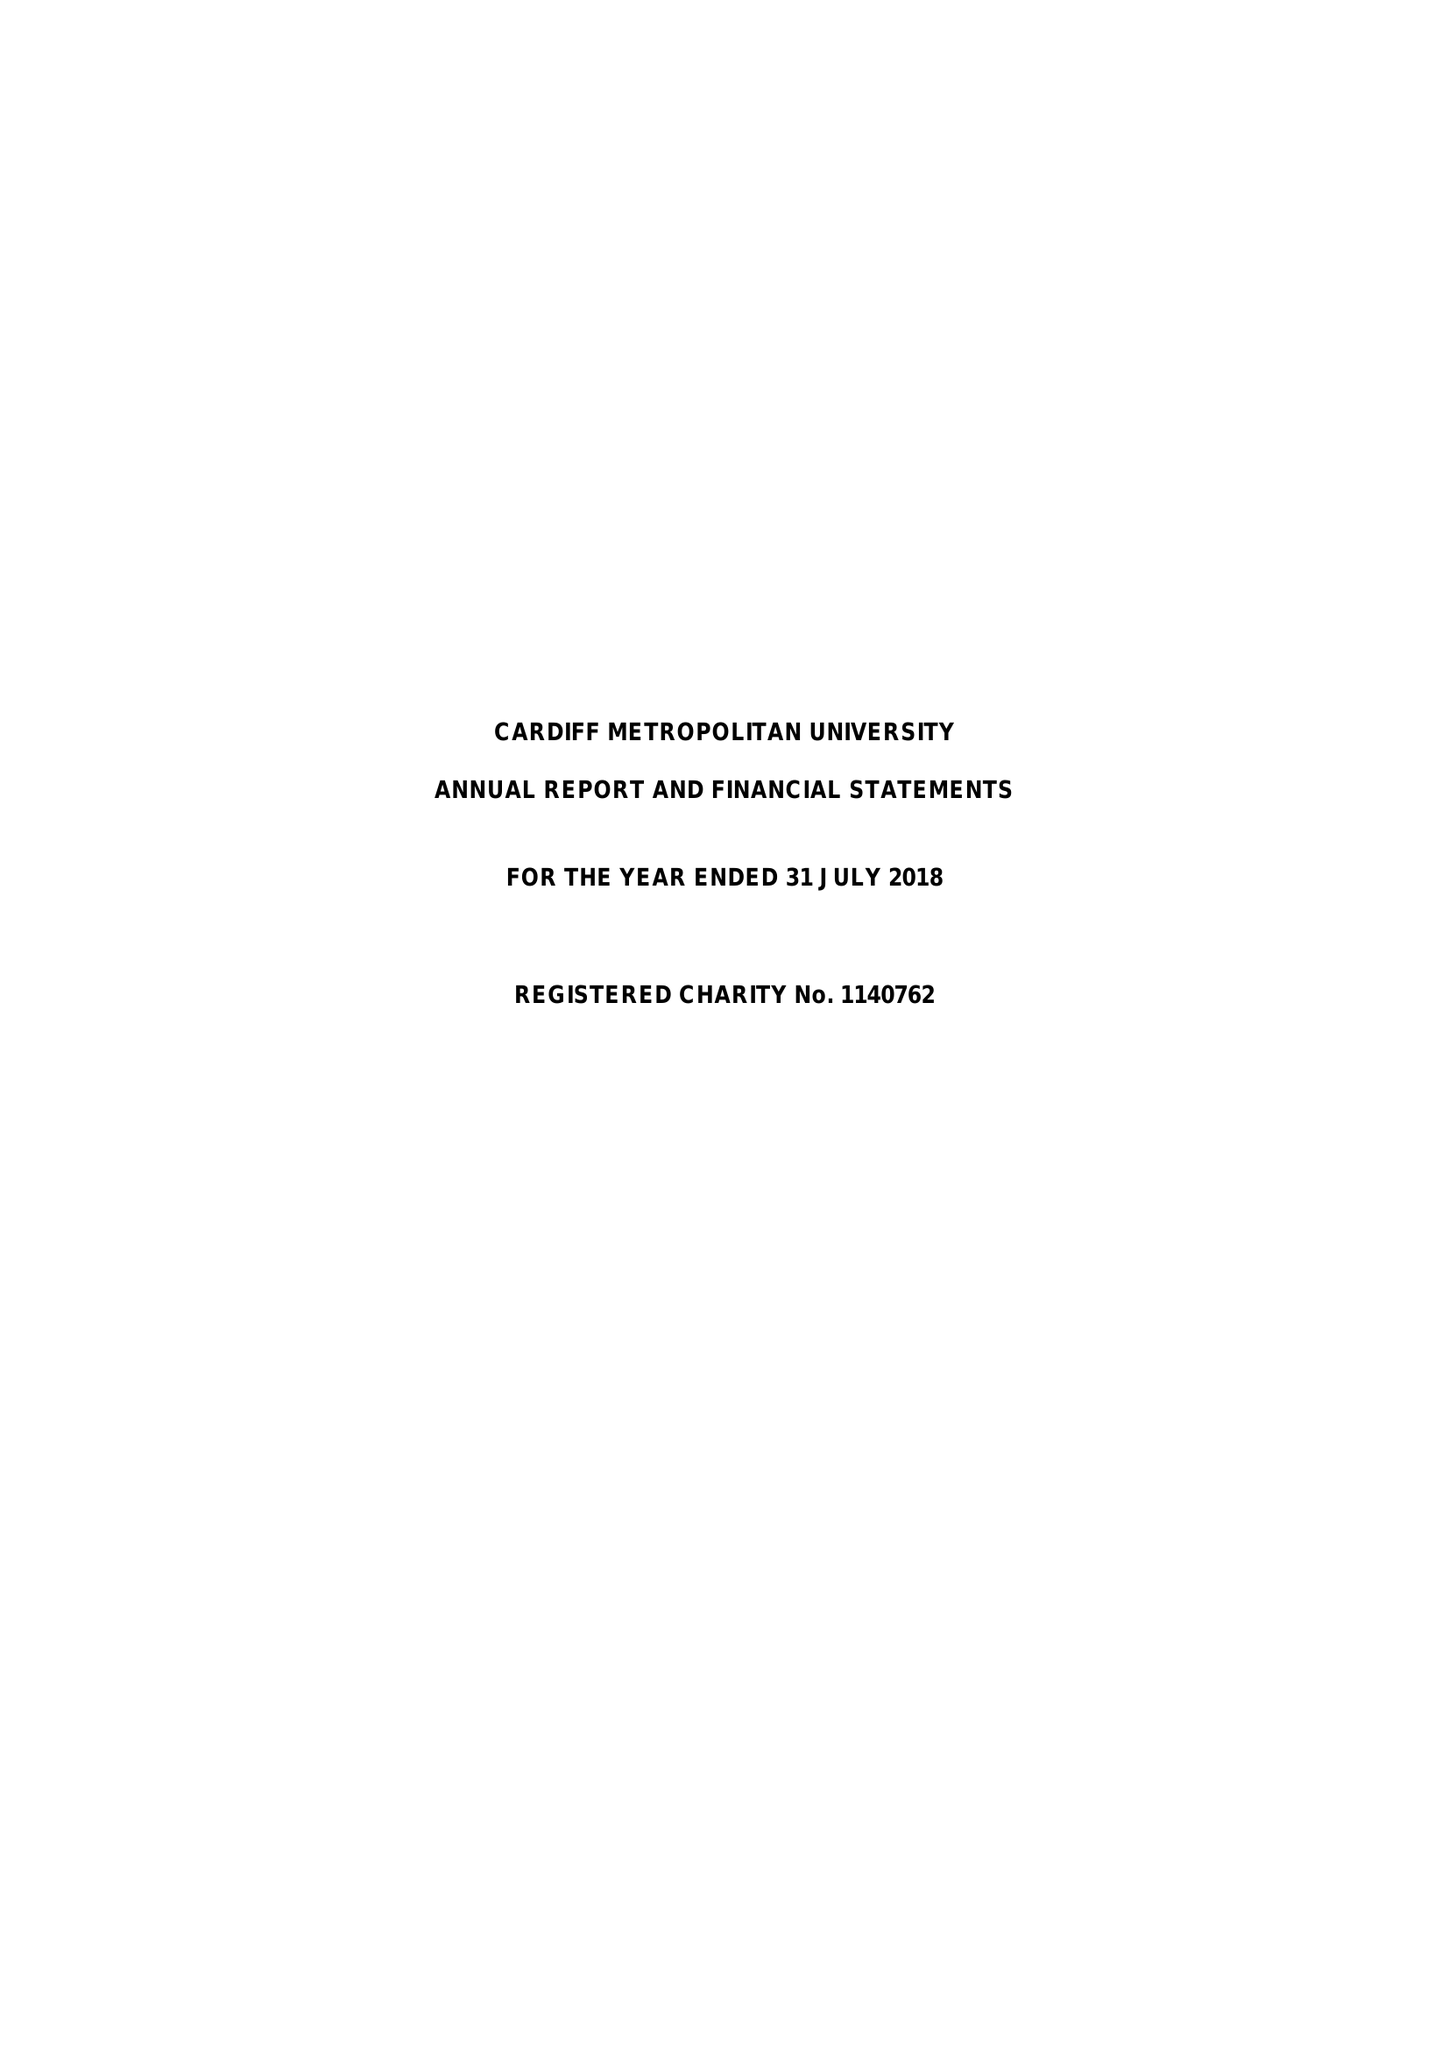What is the value for the charity_name?
Answer the question using a single word or phrase. Cardiff Metropolitan University 